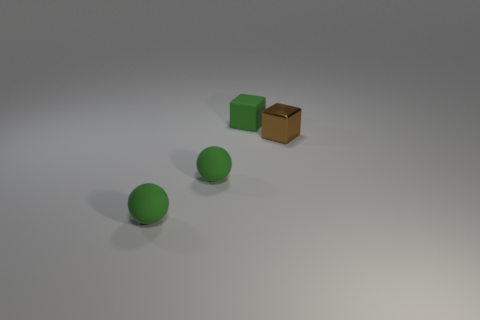Are the block that is in front of the tiny matte cube and the green block made of the same material?
Make the answer very short. No. There is a tiny rubber thing that is behind the brown thing; are there any brown metal objects that are left of it?
Offer a terse response. No. What number of other objects are the same material as the brown cube?
Give a very brief answer. 0. Are the small brown cube and the small green cube made of the same material?
Provide a succinct answer. No. How many other objects are the same color as the rubber block?
Offer a terse response. 2. How many small things are either shiny blocks or blue balls?
Provide a succinct answer. 1. Is there a tiny ball that is behind the small block that is in front of the matte object that is behind the brown metal object?
Your answer should be compact. No. Is there a purple rubber block that has the same size as the green matte block?
Give a very brief answer. No. There is a green block that is the same size as the metallic thing; what is its material?
Ensure brevity in your answer.  Rubber. There is a shiny thing; is its size the same as the green thing behind the shiny block?
Offer a very short reply. Yes. 